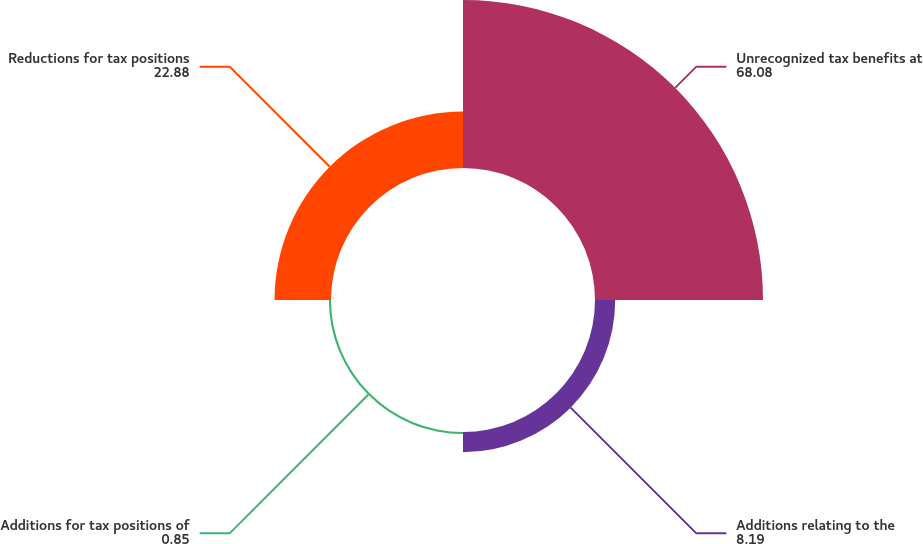Convert chart. <chart><loc_0><loc_0><loc_500><loc_500><pie_chart><fcel>Unrecognized tax benefits at<fcel>Additions relating to the<fcel>Additions for tax positions of<fcel>Reductions for tax positions<nl><fcel>68.08%<fcel>8.19%<fcel>0.85%<fcel>22.88%<nl></chart> 